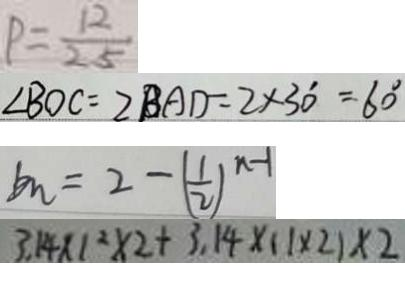<formula> <loc_0><loc_0><loc_500><loc_500>P = \frac { 1 2 } { 2 5 } 
 \angle B O C = 2 B A D = 2 \times 3 0 ^ { \circ } = 6 0 ^ { \circ } 
 b _ { n } = 2 - ( \frac { 1 } { 2 } ) ^ { n - 1 } 
 3 . 1 4 \times 1 ^ { 2 } \times 2 + 3 . 1 4 \times ( 1 \times 2 ) \times 2</formula> 